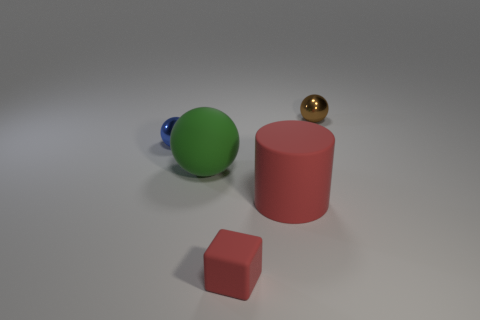What time of day or setting does this scene represent? The image looks like a studio setup with controlled lighting that does not represent a specific time of day. It's designed to focus on the objects without any external context. Could the arrangement of these objects suggest any particular theme or idea? The arrangement is fairly neutral with no clear theme, it may suggest a simplistic or minimalist perspective, highlighting basic geometric shapes and colors. 